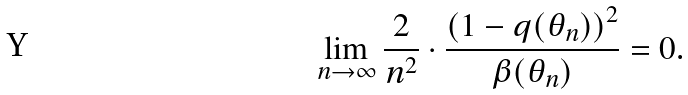Convert formula to latex. <formula><loc_0><loc_0><loc_500><loc_500>\lim _ { n \rightarrow \infty } \frac { 2 } { n ^ { 2 } } \cdot \frac { \left ( 1 - q ( \theta _ { n } ) \right ) ^ { 2 } } { \beta ( \theta _ { n } ) } = 0 .</formula> 